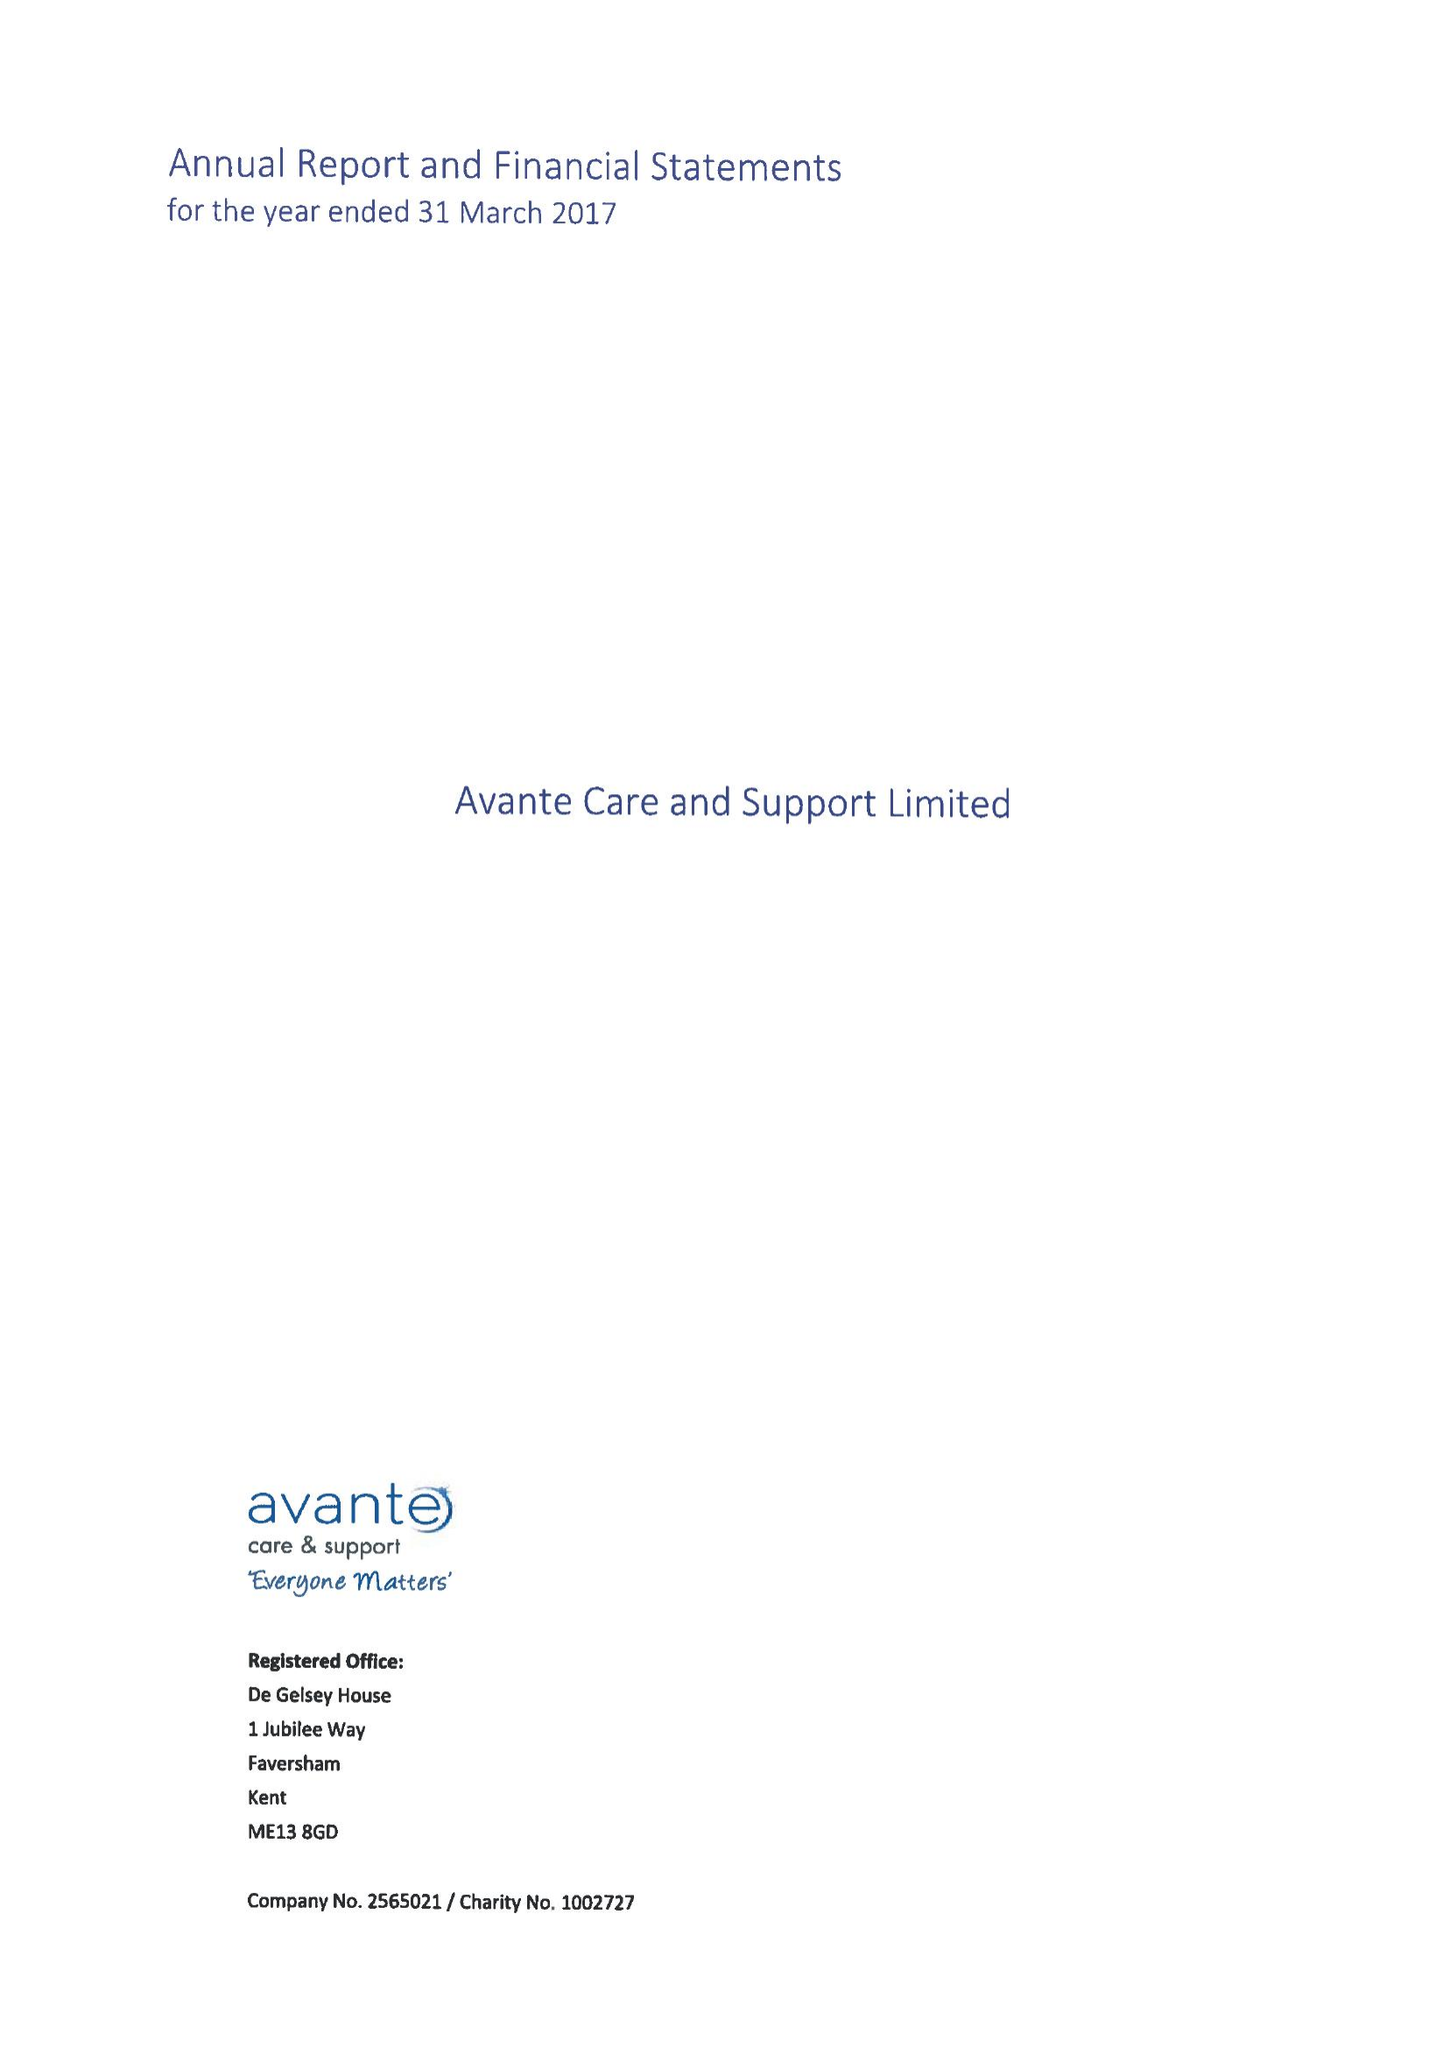What is the value for the address__postcode?
Answer the question using a single word or phrase. ME13 8GD 